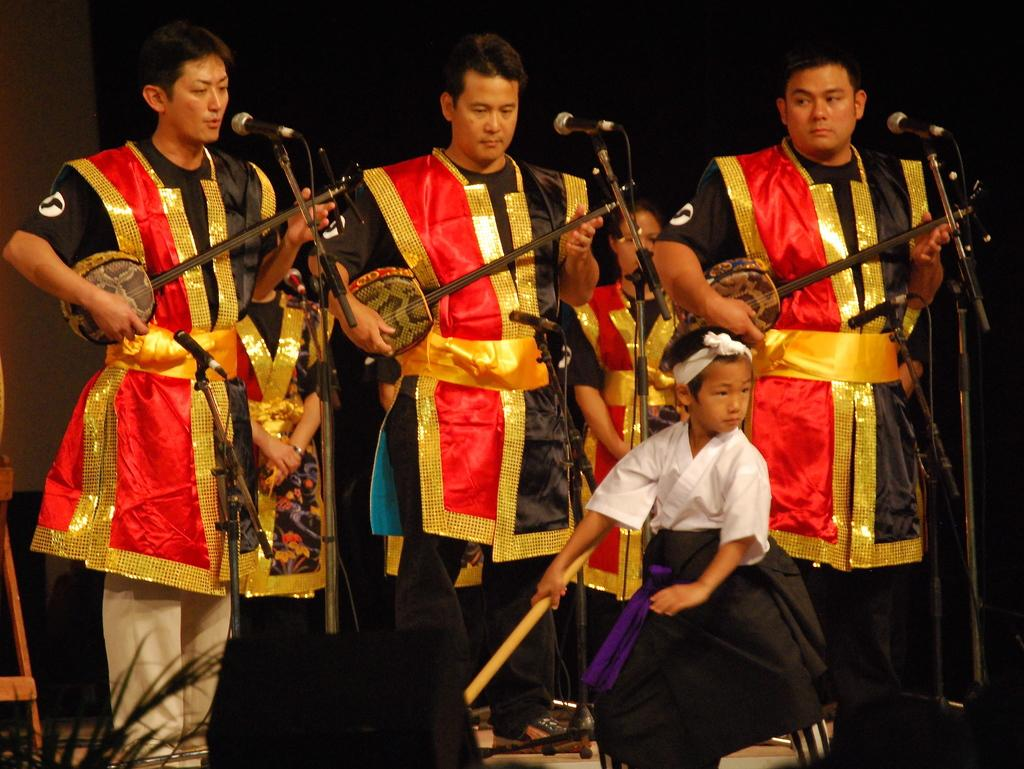Who or what can be seen in the image? There are people in the image. What are the people holding or using in the image? There are microphones (mics) and musical instruments in the image. Can you describe any other objects present in the image? There are some objects in the image. What is the color or lighting condition of the background in the image? The background of the image is dark. What type of beast can be seen in the image? There is no beast present in the image. What is the frame used for in the image? There is no frame mentioned or visible in the image. 